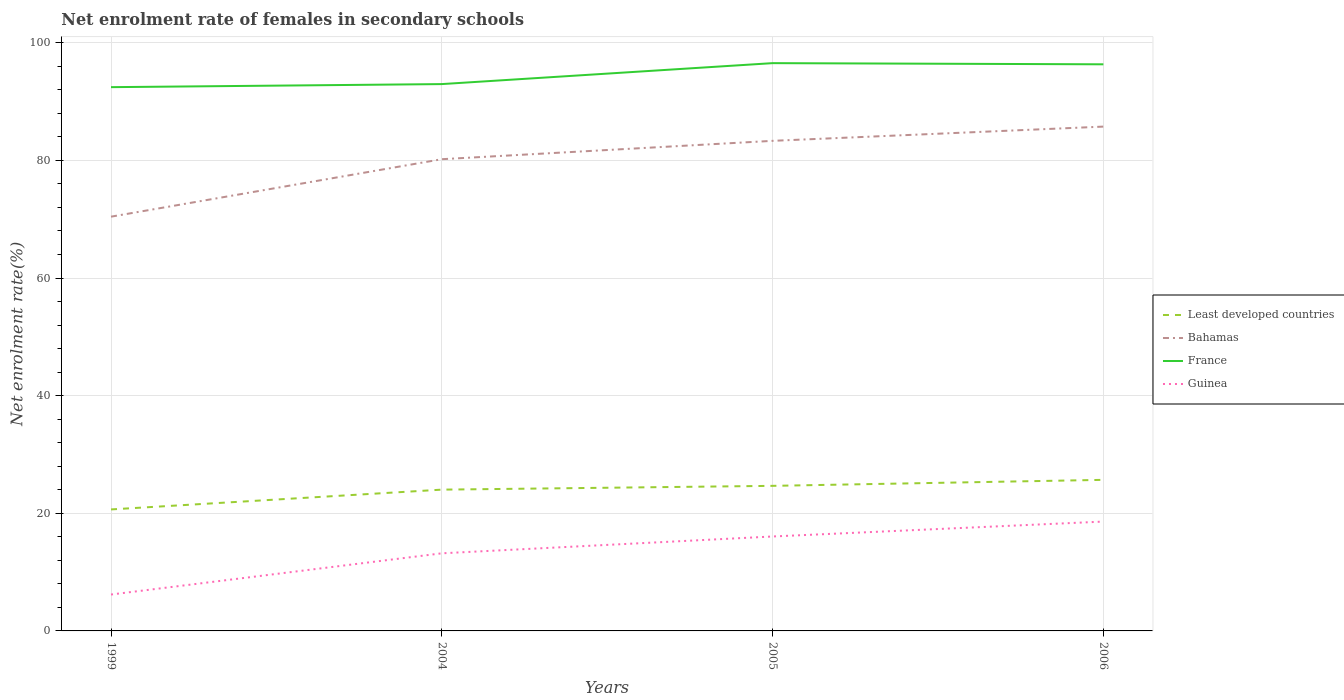How many different coloured lines are there?
Offer a very short reply. 4. Across all years, what is the maximum net enrolment rate of females in secondary schools in Least developed countries?
Provide a succinct answer. 20.66. What is the total net enrolment rate of females in secondary schools in Bahamas in the graph?
Provide a short and direct response. -3.12. What is the difference between the highest and the second highest net enrolment rate of females in secondary schools in Bahamas?
Ensure brevity in your answer.  15.31. What is the difference between the highest and the lowest net enrolment rate of females in secondary schools in Guinea?
Your answer should be very brief. 2. Is the net enrolment rate of females in secondary schools in Guinea strictly greater than the net enrolment rate of females in secondary schools in France over the years?
Your answer should be very brief. Yes. How many years are there in the graph?
Offer a very short reply. 4. Does the graph contain any zero values?
Offer a terse response. No. Does the graph contain grids?
Your response must be concise. Yes. Where does the legend appear in the graph?
Your answer should be compact. Center right. How many legend labels are there?
Provide a succinct answer. 4. How are the legend labels stacked?
Provide a short and direct response. Vertical. What is the title of the graph?
Your answer should be very brief. Net enrolment rate of females in secondary schools. What is the label or title of the Y-axis?
Provide a short and direct response. Net enrolment rate(%). What is the Net enrolment rate(%) in Least developed countries in 1999?
Your answer should be very brief. 20.66. What is the Net enrolment rate(%) of Bahamas in 1999?
Offer a very short reply. 70.43. What is the Net enrolment rate(%) in France in 1999?
Provide a succinct answer. 92.45. What is the Net enrolment rate(%) of Guinea in 1999?
Your answer should be compact. 6.19. What is the Net enrolment rate(%) in Least developed countries in 2004?
Your response must be concise. 24.02. What is the Net enrolment rate(%) in Bahamas in 2004?
Make the answer very short. 80.2. What is the Net enrolment rate(%) of France in 2004?
Your answer should be compact. 92.97. What is the Net enrolment rate(%) of Guinea in 2004?
Offer a very short reply. 13.2. What is the Net enrolment rate(%) in Least developed countries in 2005?
Keep it short and to the point. 24.67. What is the Net enrolment rate(%) of Bahamas in 2005?
Give a very brief answer. 83.32. What is the Net enrolment rate(%) of France in 2005?
Make the answer very short. 96.53. What is the Net enrolment rate(%) in Guinea in 2005?
Offer a terse response. 16.06. What is the Net enrolment rate(%) in Least developed countries in 2006?
Offer a terse response. 25.69. What is the Net enrolment rate(%) in Bahamas in 2006?
Give a very brief answer. 85.75. What is the Net enrolment rate(%) of France in 2006?
Your answer should be very brief. 96.34. What is the Net enrolment rate(%) in Guinea in 2006?
Provide a succinct answer. 18.59. Across all years, what is the maximum Net enrolment rate(%) in Least developed countries?
Give a very brief answer. 25.69. Across all years, what is the maximum Net enrolment rate(%) of Bahamas?
Ensure brevity in your answer.  85.75. Across all years, what is the maximum Net enrolment rate(%) of France?
Give a very brief answer. 96.53. Across all years, what is the maximum Net enrolment rate(%) of Guinea?
Offer a very short reply. 18.59. Across all years, what is the minimum Net enrolment rate(%) in Least developed countries?
Your response must be concise. 20.66. Across all years, what is the minimum Net enrolment rate(%) of Bahamas?
Give a very brief answer. 70.43. Across all years, what is the minimum Net enrolment rate(%) of France?
Offer a terse response. 92.45. Across all years, what is the minimum Net enrolment rate(%) of Guinea?
Your response must be concise. 6.19. What is the total Net enrolment rate(%) of Least developed countries in the graph?
Make the answer very short. 95.03. What is the total Net enrolment rate(%) of Bahamas in the graph?
Give a very brief answer. 319.7. What is the total Net enrolment rate(%) in France in the graph?
Ensure brevity in your answer.  378.29. What is the total Net enrolment rate(%) of Guinea in the graph?
Your answer should be compact. 54.03. What is the difference between the Net enrolment rate(%) of Least developed countries in 1999 and that in 2004?
Keep it short and to the point. -3.36. What is the difference between the Net enrolment rate(%) in Bahamas in 1999 and that in 2004?
Ensure brevity in your answer.  -9.77. What is the difference between the Net enrolment rate(%) of France in 1999 and that in 2004?
Offer a very short reply. -0.52. What is the difference between the Net enrolment rate(%) in Guinea in 1999 and that in 2004?
Offer a terse response. -7.01. What is the difference between the Net enrolment rate(%) in Least developed countries in 1999 and that in 2005?
Offer a terse response. -4.01. What is the difference between the Net enrolment rate(%) of Bahamas in 1999 and that in 2005?
Your answer should be very brief. -12.89. What is the difference between the Net enrolment rate(%) of France in 1999 and that in 2005?
Keep it short and to the point. -4.08. What is the difference between the Net enrolment rate(%) in Guinea in 1999 and that in 2005?
Your answer should be very brief. -9.87. What is the difference between the Net enrolment rate(%) in Least developed countries in 1999 and that in 2006?
Your answer should be very brief. -5.03. What is the difference between the Net enrolment rate(%) in Bahamas in 1999 and that in 2006?
Ensure brevity in your answer.  -15.31. What is the difference between the Net enrolment rate(%) of France in 1999 and that in 2006?
Your response must be concise. -3.88. What is the difference between the Net enrolment rate(%) in Guinea in 1999 and that in 2006?
Offer a very short reply. -12.4. What is the difference between the Net enrolment rate(%) in Least developed countries in 2004 and that in 2005?
Ensure brevity in your answer.  -0.64. What is the difference between the Net enrolment rate(%) in Bahamas in 2004 and that in 2005?
Offer a very short reply. -3.12. What is the difference between the Net enrolment rate(%) of France in 2004 and that in 2005?
Your answer should be very brief. -3.56. What is the difference between the Net enrolment rate(%) of Guinea in 2004 and that in 2005?
Give a very brief answer. -2.86. What is the difference between the Net enrolment rate(%) in Least developed countries in 2004 and that in 2006?
Your response must be concise. -1.66. What is the difference between the Net enrolment rate(%) in Bahamas in 2004 and that in 2006?
Your answer should be very brief. -5.54. What is the difference between the Net enrolment rate(%) of France in 2004 and that in 2006?
Provide a succinct answer. -3.36. What is the difference between the Net enrolment rate(%) of Guinea in 2004 and that in 2006?
Your answer should be compact. -5.4. What is the difference between the Net enrolment rate(%) of Least developed countries in 2005 and that in 2006?
Your answer should be compact. -1.02. What is the difference between the Net enrolment rate(%) in Bahamas in 2005 and that in 2006?
Your response must be concise. -2.42. What is the difference between the Net enrolment rate(%) in France in 2005 and that in 2006?
Offer a terse response. 0.2. What is the difference between the Net enrolment rate(%) of Guinea in 2005 and that in 2006?
Provide a succinct answer. -2.54. What is the difference between the Net enrolment rate(%) in Least developed countries in 1999 and the Net enrolment rate(%) in Bahamas in 2004?
Your answer should be compact. -59.55. What is the difference between the Net enrolment rate(%) in Least developed countries in 1999 and the Net enrolment rate(%) in France in 2004?
Provide a succinct answer. -72.32. What is the difference between the Net enrolment rate(%) of Least developed countries in 1999 and the Net enrolment rate(%) of Guinea in 2004?
Ensure brevity in your answer.  7.46. What is the difference between the Net enrolment rate(%) in Bahamas in 1999 and the Net enrolment rate(%) in France in 2004?
Keep it short and to the point. -22.54. What is the difference between the Net enrolment rate(%) of Bahamas in 1999 and the Net enrolment rate(%) of Guinea in 2004?
Your answer should be very brief. 57.24. What is the difference between the Net enrolment rate(%) of France in 1999 and the Net enrolment rate(%) of Guinea in 2004?
Make the answer very short. 79.26. What is the difference between the Net enrolment rate(%) in Least developed countries in 1999 and the Net enrolment rate(%) in Bahamas in 2005?
Provide a short and direct response. -62.67. What is the difference between the Net enrolment rate(%) of Least developed countries in 1999 and the Net enrolment rate(%) of France in 2005?
Give a very brief answer. -75.88. What is the difference between the Net enrolment rate(%) in Least developed countries in 1999 and the Net enrolment rate(%) in Guinea in 2005?
Provide a short and direct response. 4.6. What is the difference between the Net enrolment rate(%) of Bahamas in 1999 and the Net enrolment rate(%) of France in 2005?
Your answer should be very brief. -26.1. What is the difference between the Net enrolment rate(%) in Bahamas in 1999 and the Net enrolment rate(%) in Guinea in 2005?
Offer a very short reply. 54.37. What is the difference between the Net enrolment rate(%) of France in 1999 and the Net enrolment rate(%) of Guinea in 2005?
Your response must be concise. 76.39. What is the difference between the Net enrolment rate(%) in Least developed countries in 1999 and the Net enrolment rate(%) in Bahamas in 2006?
Ensure brevity in your answer.  -65.09. What is the difference between the Net enrolment rate(%) of Least developed countries in 1999 and the Net enrolment rate(%) of France in 2006?
Your answer should be compact. -75.68. What is the difference between the Net enrolment rate(%) of Least developed countries in 1999 and the Net enrolment rate(%) of Guinea in 2006?
Provide a succinct answer. 2.07. What is the difference between the Net enrolment rate(%) in Bahamas in 1999 and the Net enrolment rate(%) in France in 2006?
Keep it short and to the point. -25.9. What is the difference between the Net enrolment rate(%) of Bahamas in 1999 and the Net enrolment rate(%) of Guinea in 2006?
Ensure brevity in your answer.  51.84. What is the difference between the Net enrolment rate(%) of France in 1999 and the Net enrolment rate(%) of Guinea in 2006?
Ensure brevity in your answer.  73.86. What is the difference between the Net enrolment rate(%) in Least developed countries in 2004 and the Net enrolment rate(%) in Bahamas in 2005?
Your answer should be compact. -59.3. What is the difference between the Net enrolment rate(%) in Least developed countries in 2004 and the Net enrolment rate(%) in France in 2005?
Your answer should be compact. -72.51. What is the difference between the Net enrolment rate(%) in Least developed countries in 2004 and the Net enrolment rate(%) in Guinea in 2005?
Ensure brevity in your answer.  7.96. What is the difference between the Net enrolment rate(%) of Bahamas in 2004 and the Net enrolment rate(%) of France in 2005?
Ensure brevity in your answer.  -16.33. What is the difference between the Net enrolment rate(%) of Bahamas in 2004 and the Net enrolment rate(%) of Guinea in 2005?
Provide a succinct answer. 64.15. What is the difference between the Net enrolment rate(%) in France in 2004 and the Net enrolment rate(%) in Guinea in 2005?
Provide a succinct answer. 76.92. What is the difference between the Net enrolment rate(%) of Least developed countries in 2004 and the Net enrolment rate(%) of Bahamas in 2006?
Your answer should be compact. -61.72. What is the difference between the Net enrolment rate(%) in Least developed countries in 2004 and the Net enrolment rate(%) in France in 2006?
Give a very brief answer. -72.31. What is the difference between the Net enrolment rate(%) of Least developed countries in 2004 and the Net enrolment rate(%) of Guinea in 2006?
Offer a terse response. 5.43. What is the difference between the Net enrolment rate(%) in Bahamas in 2004 and the Net enrolment rate(%) in France in 2006?
Offer a very short reply. -16.13. What is the difference between the Net enrolment rate(%) in Bahamas in 2004 and the Net enrolment rate(%) in Guinea in 2006?
Offer a terse response. 61.61. What is the difference between the Net enrolment rate(%) of France in 2004 and the Net enrolment rate(%) of Guinea in 2006?
Your response must be concise. 74.38. What is the difference between the Net enrolment rate(%) of Least developed countries in 2005 and the Net enrolment rate(%) of Bahamas in 2006?
Provide a succinct answer. -61.08. What is the difference between the Net enrolment rate(%) of Least developed countries in 2005 and the Net enrolment rate(%) of France in 2006?
Your response must be concise. -71.67. What is the difference between the Net enrolment rate(%) in Least developed countries in 2005 and the Net enrolment rate(%) in Guinea in 2006?
Offer a very short reply. 6.07. What is the difference between the Net enrolment rate(%) in Bahamas in 2005 and the Net enrolment rate(%) in France in 2006?
Provide a succinct answer. -13.01. What is the difference between the Net enrolment rate(%) in Bahamas in 2005 and the Net enrolment rate(%) in Guinea in 2006?
Your response must be concise. 64.73. What is the difference between the Net enrolment rate(%) in France in 2005 and the Net enrolment rate(%) in Guinea in 2006?
Your response must be concise. 77.94. What is the average Net enrolment rate(%) in Least developed countries per year?
Provide a succinct answer. 23.76. What is the average Net enrolment rate(%) in Bahamas per year?
Offer a very short reply. 79.93. What is the average Net enrolment rate(%) of France per year?
Offer a terse response. 94.57. What is the average Net enrolment rate(%) in Guinea per year?
Your response must be concise. 13.51. In the year 1999, what is the difference between the Net enrolment rate(%) of Least developed countries and Net enrolment rate(%) of Bahamas?
Your answer should be compact. -49.77. In the year 1999, what is the difference between the Net enrolment rate(%) in Least developed countries and Net enrolment rate(%) in France?
Make the answer very short. -71.79. In the year 1999, what is the difference between the Net enrolment rate(%) in Least developed countries and Net enrolment rate(%) in Guinea?
Your response must be concise. 14.47. In the year 1999, what is the difference between the Net enrolment rate(%) of Bahamas and Net enrolment rate(%) of France?
Make the answer very short. -22.02. In the year 1999, what is the difference between the Net enrolment rate(%) in Bahamas and Net enrolment rate(%) in Guinea?
Keep it short and to the point. 64.24. In the year 1999, what is the difference between the Net enrolment rate(%) in France and Net enrolment rate(%) in Guinea?
Make the answer very short. 86.26. In the year 2004, what is the difference between the Net enrolment rate(%) in Least developed countries and Net enrolment rate(%) in Bahamas?
Ensure brevity in your answer.  -56.18. In the year 2004, what is the difference between the Net enrolment rate(%) in Least developed countries and Net enrolment rate(%) in France?
Provide a succinct answer. -68.95. In the year 2004, what is the difference between the Net enrolment rate(%) of Least developed countries and Net enrolment rate(%) of Guinea?
Ensure brevity in your answer.  10.83. In the year 2004, what is the difference between the Net enrolment rate(%) in Bahamas and Net enrolment rate(%) in France?
Provide a short and direct response. -12.77. In the year 2004, what is the difference between the Net enrolment rate(%) in Bahamas and Net enrolment rate(%) in Guinea?
Make the answer very short. 67.01. In the year 2004, what is the difference between the Net enrolment rate(%) of France and Net enrolment rate(%) of Guinea?
Keep it short and to the point. 79.78. In the year 2005, what is the difference between the Net enrolment rate(%) in Least developed countries and Net enrolment rate(%) in Bahamas?
Offer a terse response. -58.66. In the year 2005, what is the difference between the Net enrolment rate(%) of Least developed countries and Net enrolment rate(%) of France?
Keep it short and to the point. -71.87. In the year 2005, what is the difference between the Net enrolment rate(%) of Least developed countries and Net enrolment rate(%) of Guinea?
Give a very brief answer. 8.61. In the year 2005, what is the difference between the Net enrolment rate(%) in Bahamas and Net enrolment rate(%) in France?
Provide a succinct answer. -13.21. In the year 2005, what is the difference between the Net enrolment rate(%) in Bahamas and Net enrolment rate(%) in Guinea?
Give a very brief answer. 67.27. In the year 2005, what is the difference between the Net enrolment rate(%) in France and Net enrolment rate(%) in Guinea?
Provide a succinct answer. 80.48. In the year 2006, what is the difference between the Net enrolment rate(%) in Least developed countries and Net enrolment rate(%) in Bahamas?
Give a very brief answer. -60.06. In the year 2006, what is the difference between the Net enrolment rate(%) of Least developed countries and Net enrolment rate(%) of France?
Offer a very short reply. -70.65. In the year 2006, what is the difference between the Net enrolment rate(%) in Least developed countries and Net enrolment rate(%) in Guinea?
Ensure brevity in your answer.  7.09. In the year 2006, what is the difference between the Net enrolment rate(%) of Bahamas and Net enrolment rate(%) of France?
Your answer should be compact. -10.59. In the year 2006, what is the difference between the Net enrolment rate(%) of Bahamas and Net enrolment rate(%) of Guinea?
Offer a very short reply. 67.15. In the year 2006, what is the difference between the Net enrolment rate(%) of France and Net enrolment rate(%) of Guinea?
Keep it short and to the point. 77.74. What is the ratio of the Net enrolment rate(%) of Least developed countries in 1999 to that in 2004?
Make the answer very short. 0.86. What is the ratio of the Net enrolment rate(%) in Bahamas in 1999 to that in 2004?
Keep it short and to the point. 0.88. What is the ratio of the Net enrolment rate(%) in France in 1999 to that in 2004?
Your answer should be compact. 0.99. What is the ratio of the Net enrolment rate(%) in Guinea in 1999 to that in 2004?
Offer a terse response. 0.47. What is the ratio of the Net enrolment rate(%) in Least developed countries in 1999 to that in 2005?
Offer a very short reply. 0.84. What is the ratio of the Net enrolment rate(%) in Bahamas in 1999 to that in 2005?
Make the answer very short. 0.85. What is the ratio of the Net enrolment rate(%) of France in 1999 to that in 2005?
Offer a terse response. 0.96. What is the ratio of the Net enrolment rate(%) of Guinea in 1999 to that in 2005?
Your answer should be compact. 0.39. What is the ratio of the Net enrolment rate(%) of Least developed countries in 1999 to that in 2006?
Offer a terse response. 0.8. What is the ratio of the Net enrolment rate(%) of Bahamas in 1999 to that in 2006?
Keep it short and to the point. 0.82. What is the ratio of the Net enrolment rate(%) in France in 1999 to that in 2006?
Keep it short and to the point. 0.96. What is the ratio of the Net enrolment rate(%) of Guinea in 1999 to that in 2006?
Offer a very short reply. 0.33. What is the ratio of the Net enrolment rate(%) in Least developed countries in 2004 to that in 2005?
Keep it short and to the point. 0.97. What is the ratio of the Net enrolment rate(%) of Bahamas in 2004 to that in 2005?
Keep it short and to the point. 0.96. What is the ratio of the Net enrolment rate(%) of France in 2004 to that in 2005?
Provide a short and direct response. 0.96. What is the ratio of the Net enrolment rate(%) of Guinea in 2004 to that in 2005?
Keep it short and to the point. 0.82. What is the ratio of the Net enrolment rate(%) in Least developed countries in 2004 to that in 2006?
Your answer should be compact. 0.94. What is the ratio of the Net enrolment rate(%) in Bahamas in 2004 to that in 2006?
Provide a short and direct response. 0.94. What is the ratio of the Net enrolment rate(%) in France in 2004 to that in 2006?
Provide a succinct answer. 0.97. What is the ratio of the Net enrolment rate(%) of Guinea in 2004 to that in 2006?
Offer a terse response. 0.71. What is the ratio of the Net enrolment rate(%) in Least developed countries in 2005 to that in 2006?
Your answer should be very brief. 0.96. What is the ratio of the Net enrolment rate(%) in Bahamas in 2005 to that in 2006?
Keep it short and to the point. 0.97. What is the ratio of the Net enrolment rate(%) in France in 2005 to that in 2006?
Provide a short and direct response. 1. What is the ratio of the Net enrolment rate(%) in Guinea in 2005 to that in 2006?
Provide a succinct answer. 0.86. What is the difference between the highest and the second highest Net enrolment rate(%) of Least developed countries?
Ensure brevity in your answer.  1.02. What is the difference between the highest and the second highest Net enrolment rate(%) in Bahamas?
Provide a succinct answer. 2.42. What is the difference between the highest and the second highest Net enrolment rate(%) in France?
Keep it short and to the point. 0.2. What is the difference between the highest and the second highest Net enrolment rate(%) of Guinea?
Your answer should be very brief. 2.54. What is the difference between the highest and the lowest Net enrolment rate(%) of Least developed countries?
Keep it short and to the point. 5.03. What is the difference between the highest and the lowest Net enrolment rate(%) of Bahamas?
Ensure brevity in your answer.  15.31. What is the difference between the highest and the lowest Net enrolment rate(%) in France?
Make the answer very short. 4.08. What is the difference between the highest and the lowest Net enrolment rate(%) in Guinea?
Give a very brief answer. 12.4. 